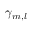Convert formula to latex. <formula><loc_0><loc_0><loc_500><loc_500>\gamma _ { m , l }</formula> 